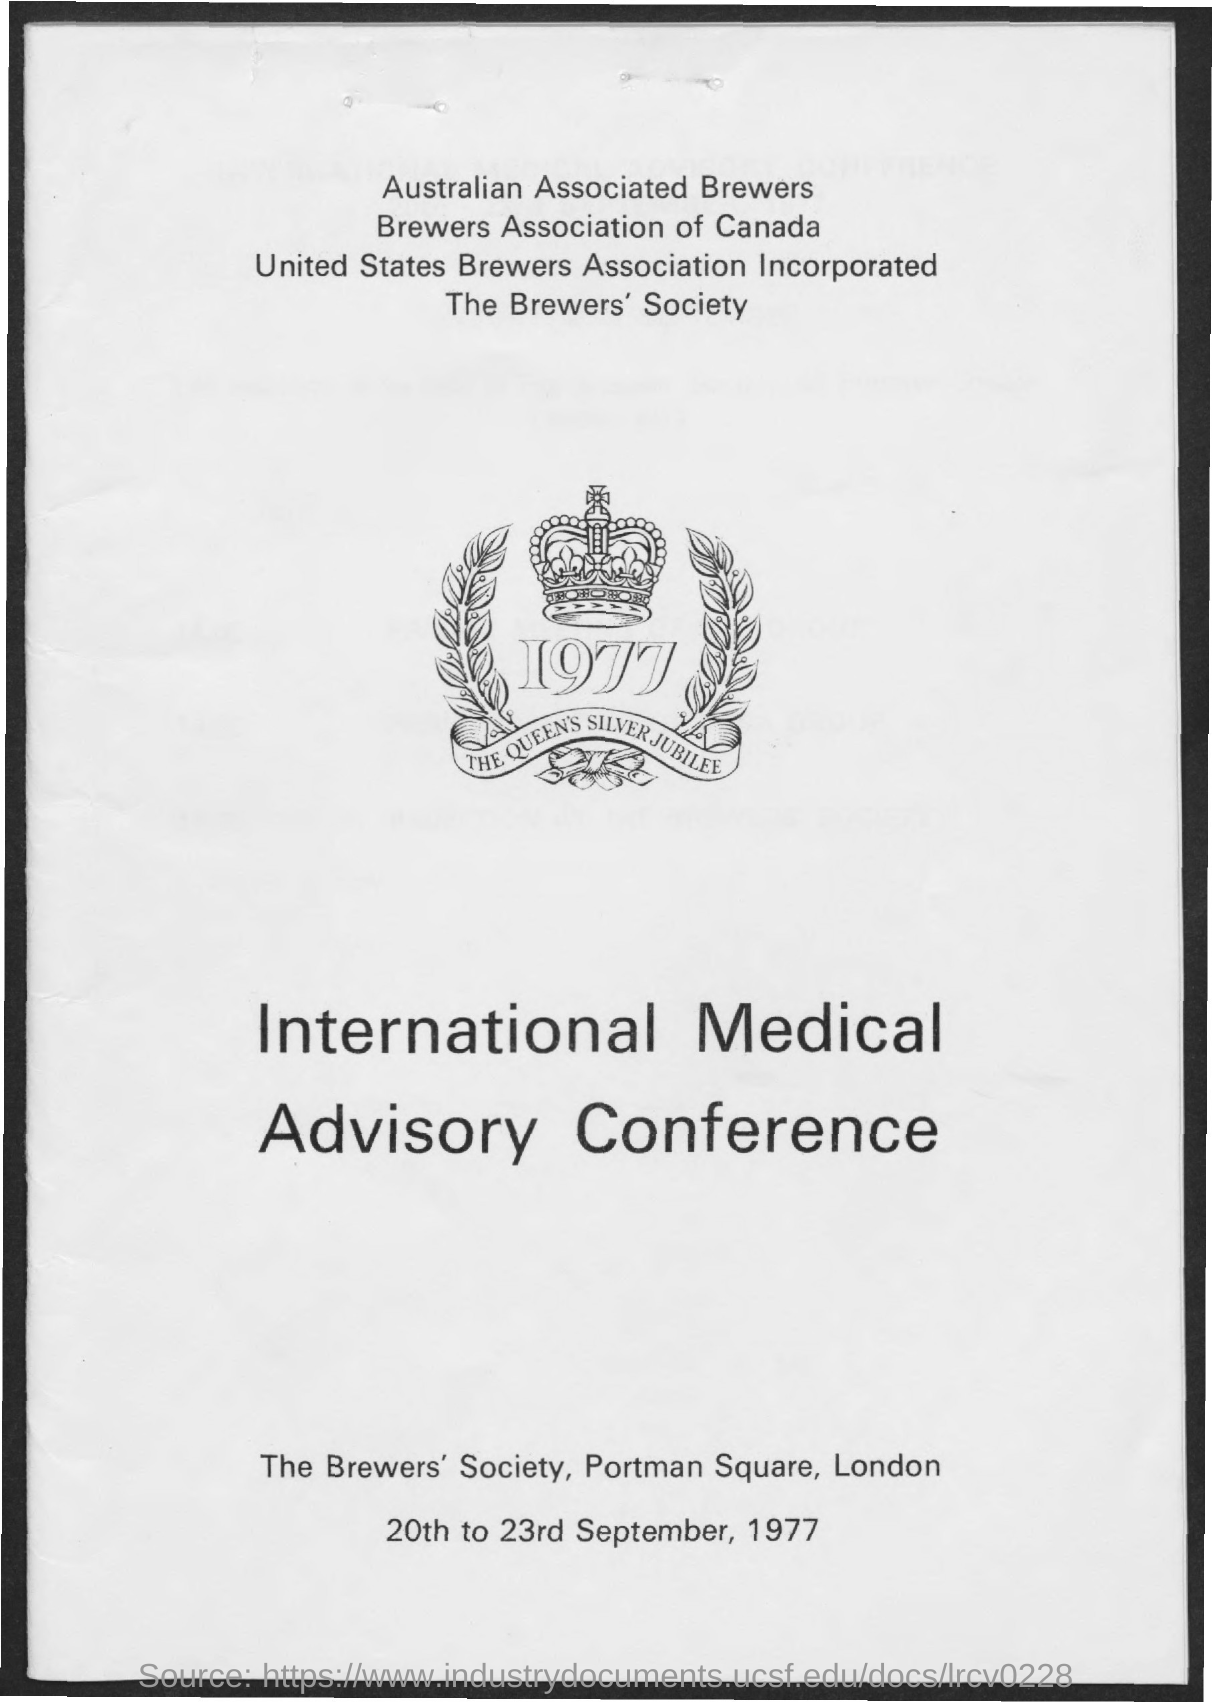What is the name of the conference mentioned ?
Offer a very short reply. International Medical Advisory Conference. What is the date mentioned in the given page ?
Offer a very short reply. 20th to 23rd September, 1977. 